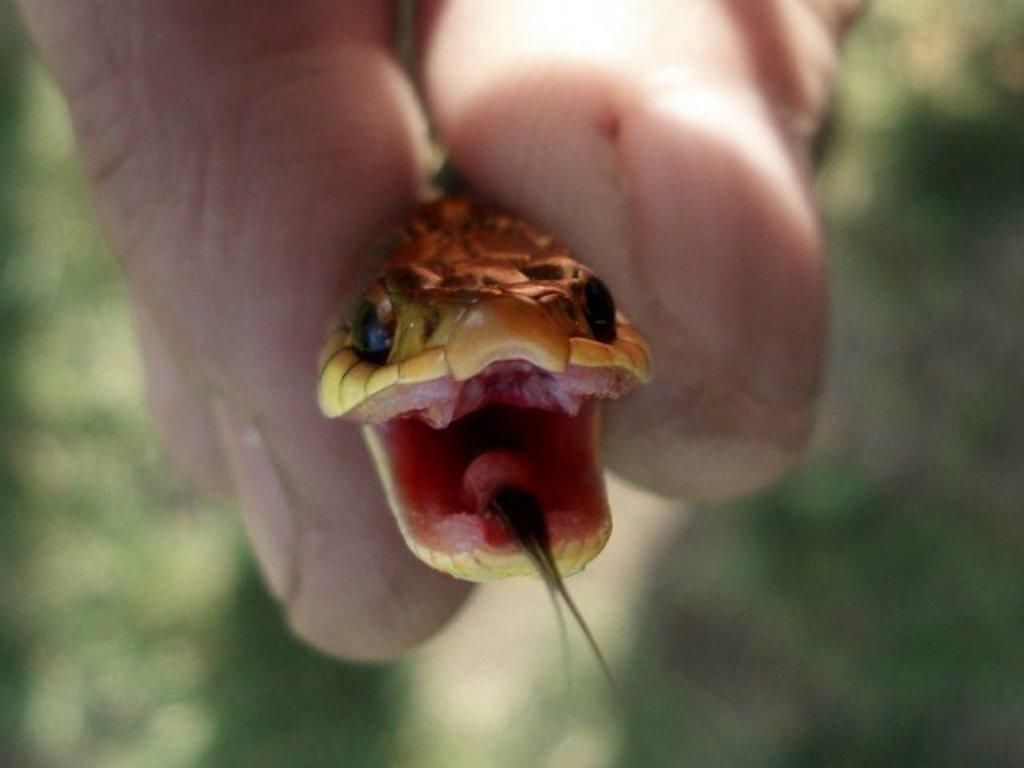In one or two sentences, can you explain what this image depicts? In this image a person is holding a snake. In the background there are trees. The background is blurry. 